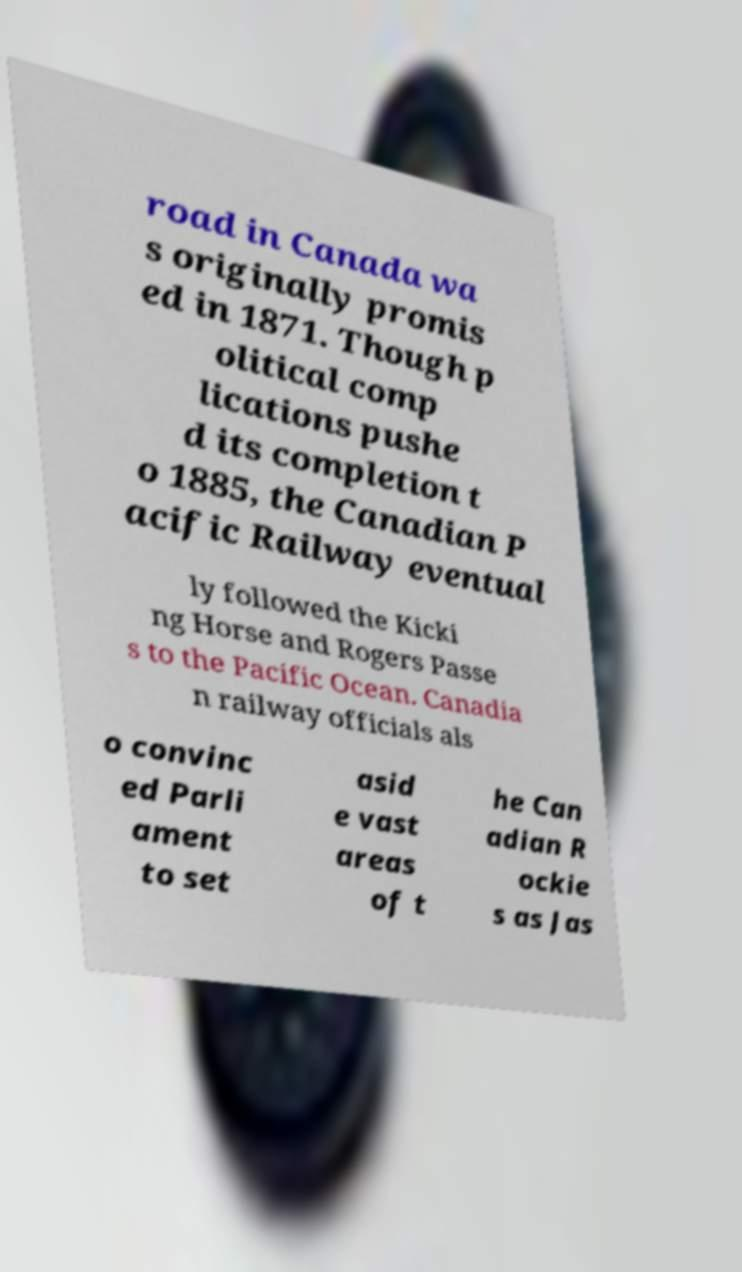Can you read and provide the text displayed in the image?This photo seems to have some interesting text. Can you extract and type it out for me? road in Canada wa s originally promis ed in 1871. Though p olitical comp lications pushe d its completion t o 1885, the Canadian P acific Railway eventual ly followed the Kicki ng Horse and Rogers Passe s to the Pacific Ocean. Canadia n railway officials als o convinc ed Parli ament to set asid e vast areas of t he Can adian R ockie s as Jas 